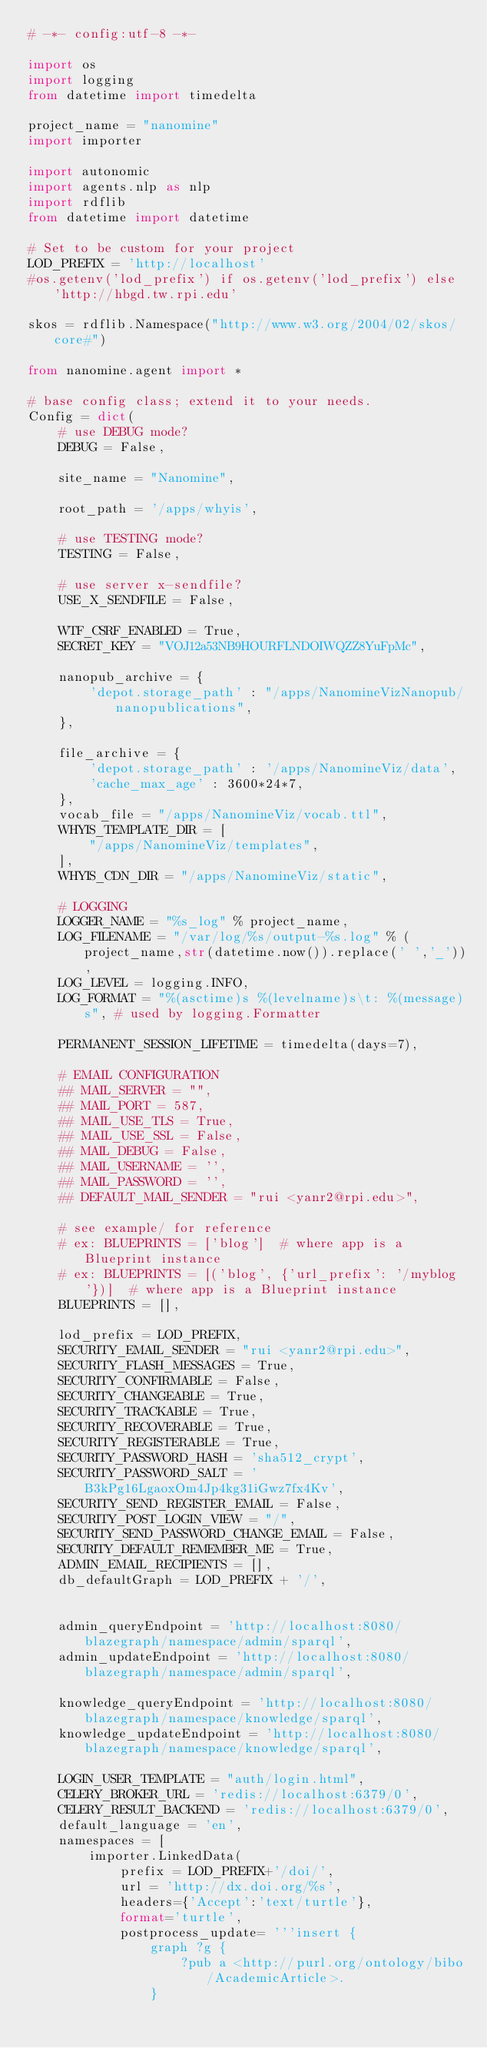<code> <loc_0><loc_0><loc_500><loc_500><_Python_># -*- config:utf-8 -*-

import os
import logging
from datetime import timedelta

project_name = "nanomine"
import importer

import autonomic
import agents.nlp as nlp
import rdflib
from datetime import datetime

# Set to be custom for your project
LOD_PREFIX = 'http://localhost'
#os.getenv('lod_prefix') if os.getenv('lod_prefix') else 'http://hbgd.tw.rpi.edu'

skos = rdflib.Namespace("http://www.w3.org/2004/02/skos/core#")

from nanomine.agent import *

# base config class; extend it to your needs.
Config = dict(
    # use DEBUG mode?
    DEBUG = False,

    site_name = "Nanomine",

    root_path = '/apps/whyis',

    # use TESTING mode?
    TESTING = False,

    # use server x-sendfile?
    USE_X_SENDFILE = False,

    WTF_CSRF_ENABLED = True,
    SECRET_KEY = "VOJ12a53NB9HOURFLNDOIWQZZ8YuFpMc",

    nanopub_archive = {
        'depot.storage_path' : "/apps/NanomineVizNanopub/nanopublications",
    },

    file_archive = {
        'depot.storage_path' : '/apps/NanomineViz/data',
        'cache_max_age' : 3600*24*7,
    },
    vocab_file = "/apps/NanomineViz/vocab.ttl",
    WHYIS_TEMPLATE_DIR = [
        "/apps/NanomineViz/templates",
    ],
    WHYIS_CDN_DIR = "/apps/NanomineViz/static",

    # LOGGING
    LOGGER_NAME = "%s_log" % project_name,
    LOG_FILENAME = "/var/log/%s/output-%s.log" % (project_name,str(datetime.now()).replace(' ','_')),
    LOG_LEVEL = logging.INFO,
    LOG_FORMAT = "%(asctime)s %(levelname)s\t: %(message)s", # used by logging.Formatter

    PERMANENT_SESSION_LIFETIME = timedelta(days=7),

    # EMAIL CONFIGURATION
    ## MAIL_SERVER = "",
    ## MAIL_PORT = 587,
    ## MAIL_USE_TLS = True,
    ## MAIL_USE_SSL = False,
    ## MAIL_DEBUG = False,
    ## MAIL_USERNAME = '',
    ## MAIL_PASSWORD = '',
    ## DEFAULT_MAIL_SENDER = "rui <yanr2@rpi.edu>",

    # see example/ for reference
    # ex: BLUEPRINTS = ['blog']  # where app is a Blueprint instance
    # ex: BLUEPRINTS = [('blog', {'url_prefix': '/myblog'})]  # where app is a Blueprint instance
    BLUEPRINTS = [],

    lod_prefix = LOD_PREFIX,
    SECURITY_EMAIL_SENDER = "rui <yanr2@rpi.edu>",
    SECURITY_FLASH_MESSAGES = True,
    SECURITY_CONFIRMABLE = False,
    SECURITY_CHANGEABLE = True,
    SECURITY_TRACKABLE = True,
    SECURITY_RECOVERABLE = True,
    SECURITY_REGISTERABLE = True,
    SECURITY_PASSWORD_HASH = 'sha512_crypt',
    SECURITY_PASSWORD_SALT = 'B3kPg16LgaoxOm4Jp4kg31iGwz7fx4Kv',
    SECURITY_SEND_REGISTER_EMAIL = False,
    SECURITY_POST_LOGIN_VIEW = "/",
    SECURITY_SEND_PASSWORD_CHANGE_EMAIL = False,
    SECURITY_DEFAULT_REMEMBER_ME = True,
    ADMIN_EMAIL_RECIPIENTS = [],
    db_defaultGraph = LOD_PREFIX + '/',


    admin_queryEndpoint = 'http://localhost:8080/blazegraph/namespace/admin/sparql',
    admin_updateEndpoint = 'http://localhost:8080/blazegraph/namespace/admin/sparql',
    
    knowledge_queryEndpoint = 'http://localhost:8080/blazegraph/namespace/knowledge/sparql',
    knowledge_updateEndpoint = 'http://localhost:8080/blazegraph/namespace/knowledge/sparql',

    LOGIN_USER_TEMPLATE = "auth/login.html",
    CELERY_BROKER_URL = 'redis://localhost:6379/0',
    CELERY_RESULT_BACKEND = 'redis://localhost:6379/0',
    default_language = 'en',
    namespaces = [
        importer.LinkedData(
            prefix = LOD_PREFIX+'/doi/',
            url = 'http://dx.doi.org/%s',
            headers={'Accept':'text/turtle'},
            format='turtle',
            postprocess_update= '''insert {
                graph ?g {
                    ?pub a <http://purl.org/ontology/bibo/AcademicArticle>.
                }</code> 